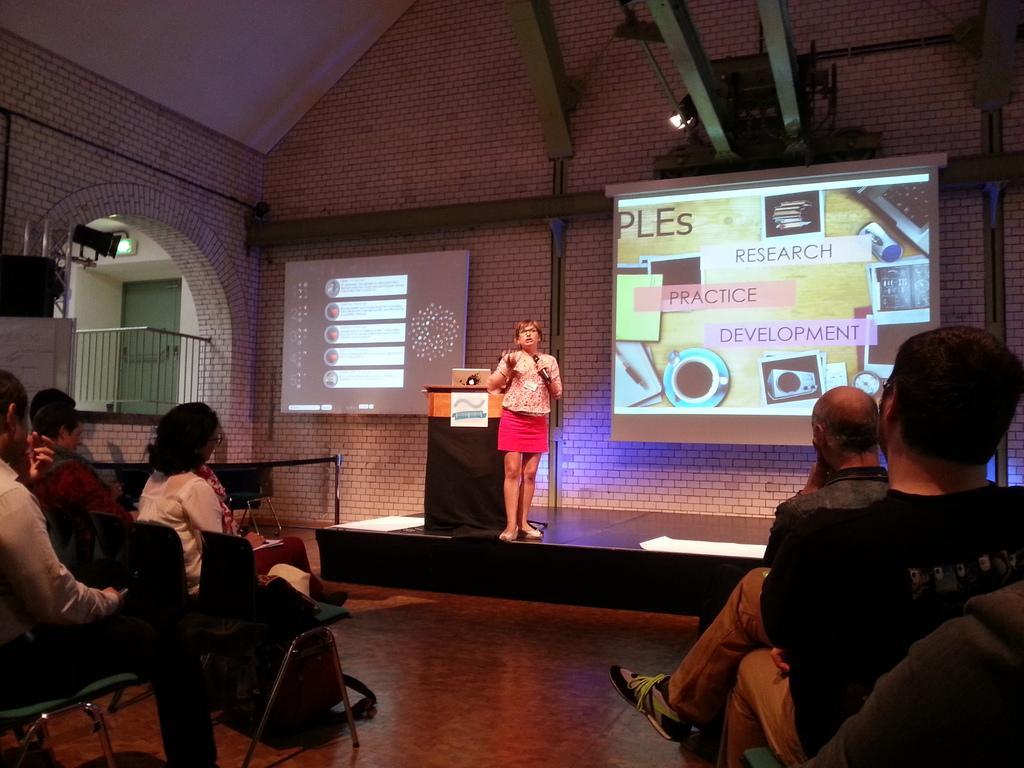Describe this image in one or two sentences. On the left side, there are persons sitting on chairs, which are on the floor. On the left side, there are persons sitting on chairs, in front of a woman, who is in skirt, and is standing on the stage, near a stand, on which, there is a laptop. In the background, there are two screens, near a wall, there is a light attached to the wall, there is a roof, there is a door and there are other objects. 